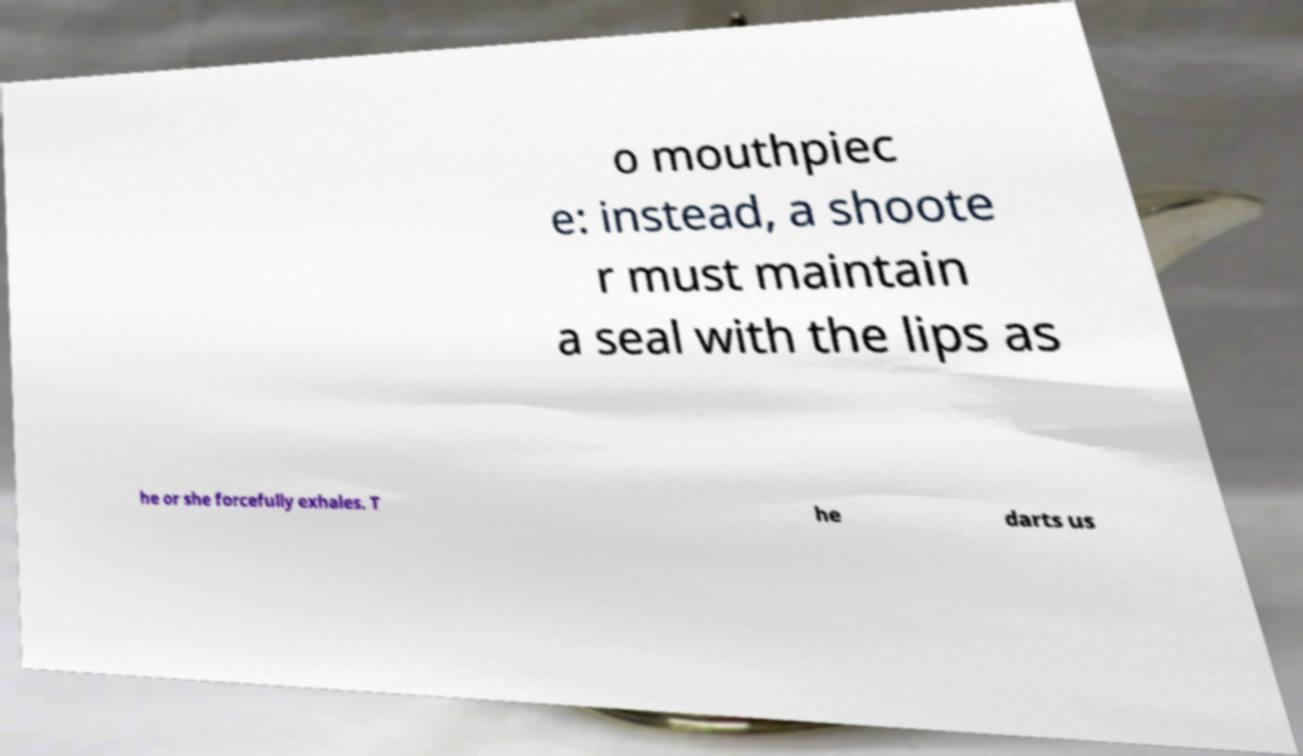Please read and relay the text visible in this image. What does it say? o mouthpiec e: instead, a shoote r must maintain a seal with the lips as he or she forcefully exhales. T he darts us 